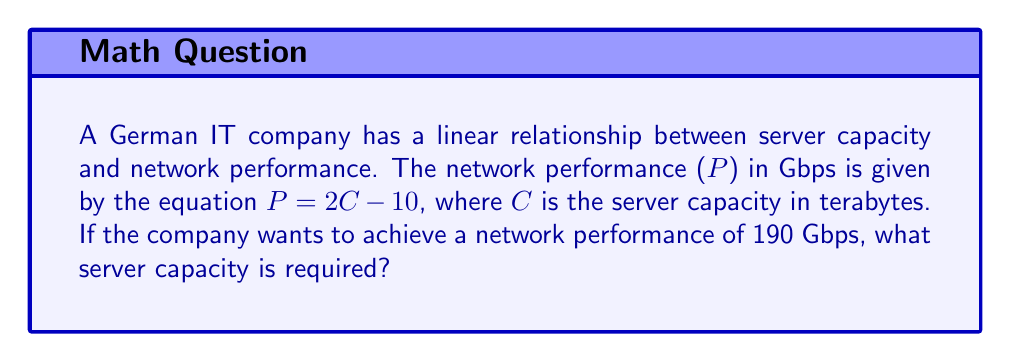Show me your answer to this math problem. To solve this problem, we'll follow these steps:

1. Identify the given equation:
   $P = 2C - 10$, where P is network performance in Gbps and C is server capacity in terabytes.

2. Substitute the desired network performance:
   $190 = 2C - 10$

3. Solve for C:
   $190 + 10 = 2C$
   $200 = 2C$

4. Divide both sides by 2:
   $\frac{200}{2} = C$
   $100 = C$

Therefore, the required server capacity is 100 terabytes.
Answer: 100 terabytes 